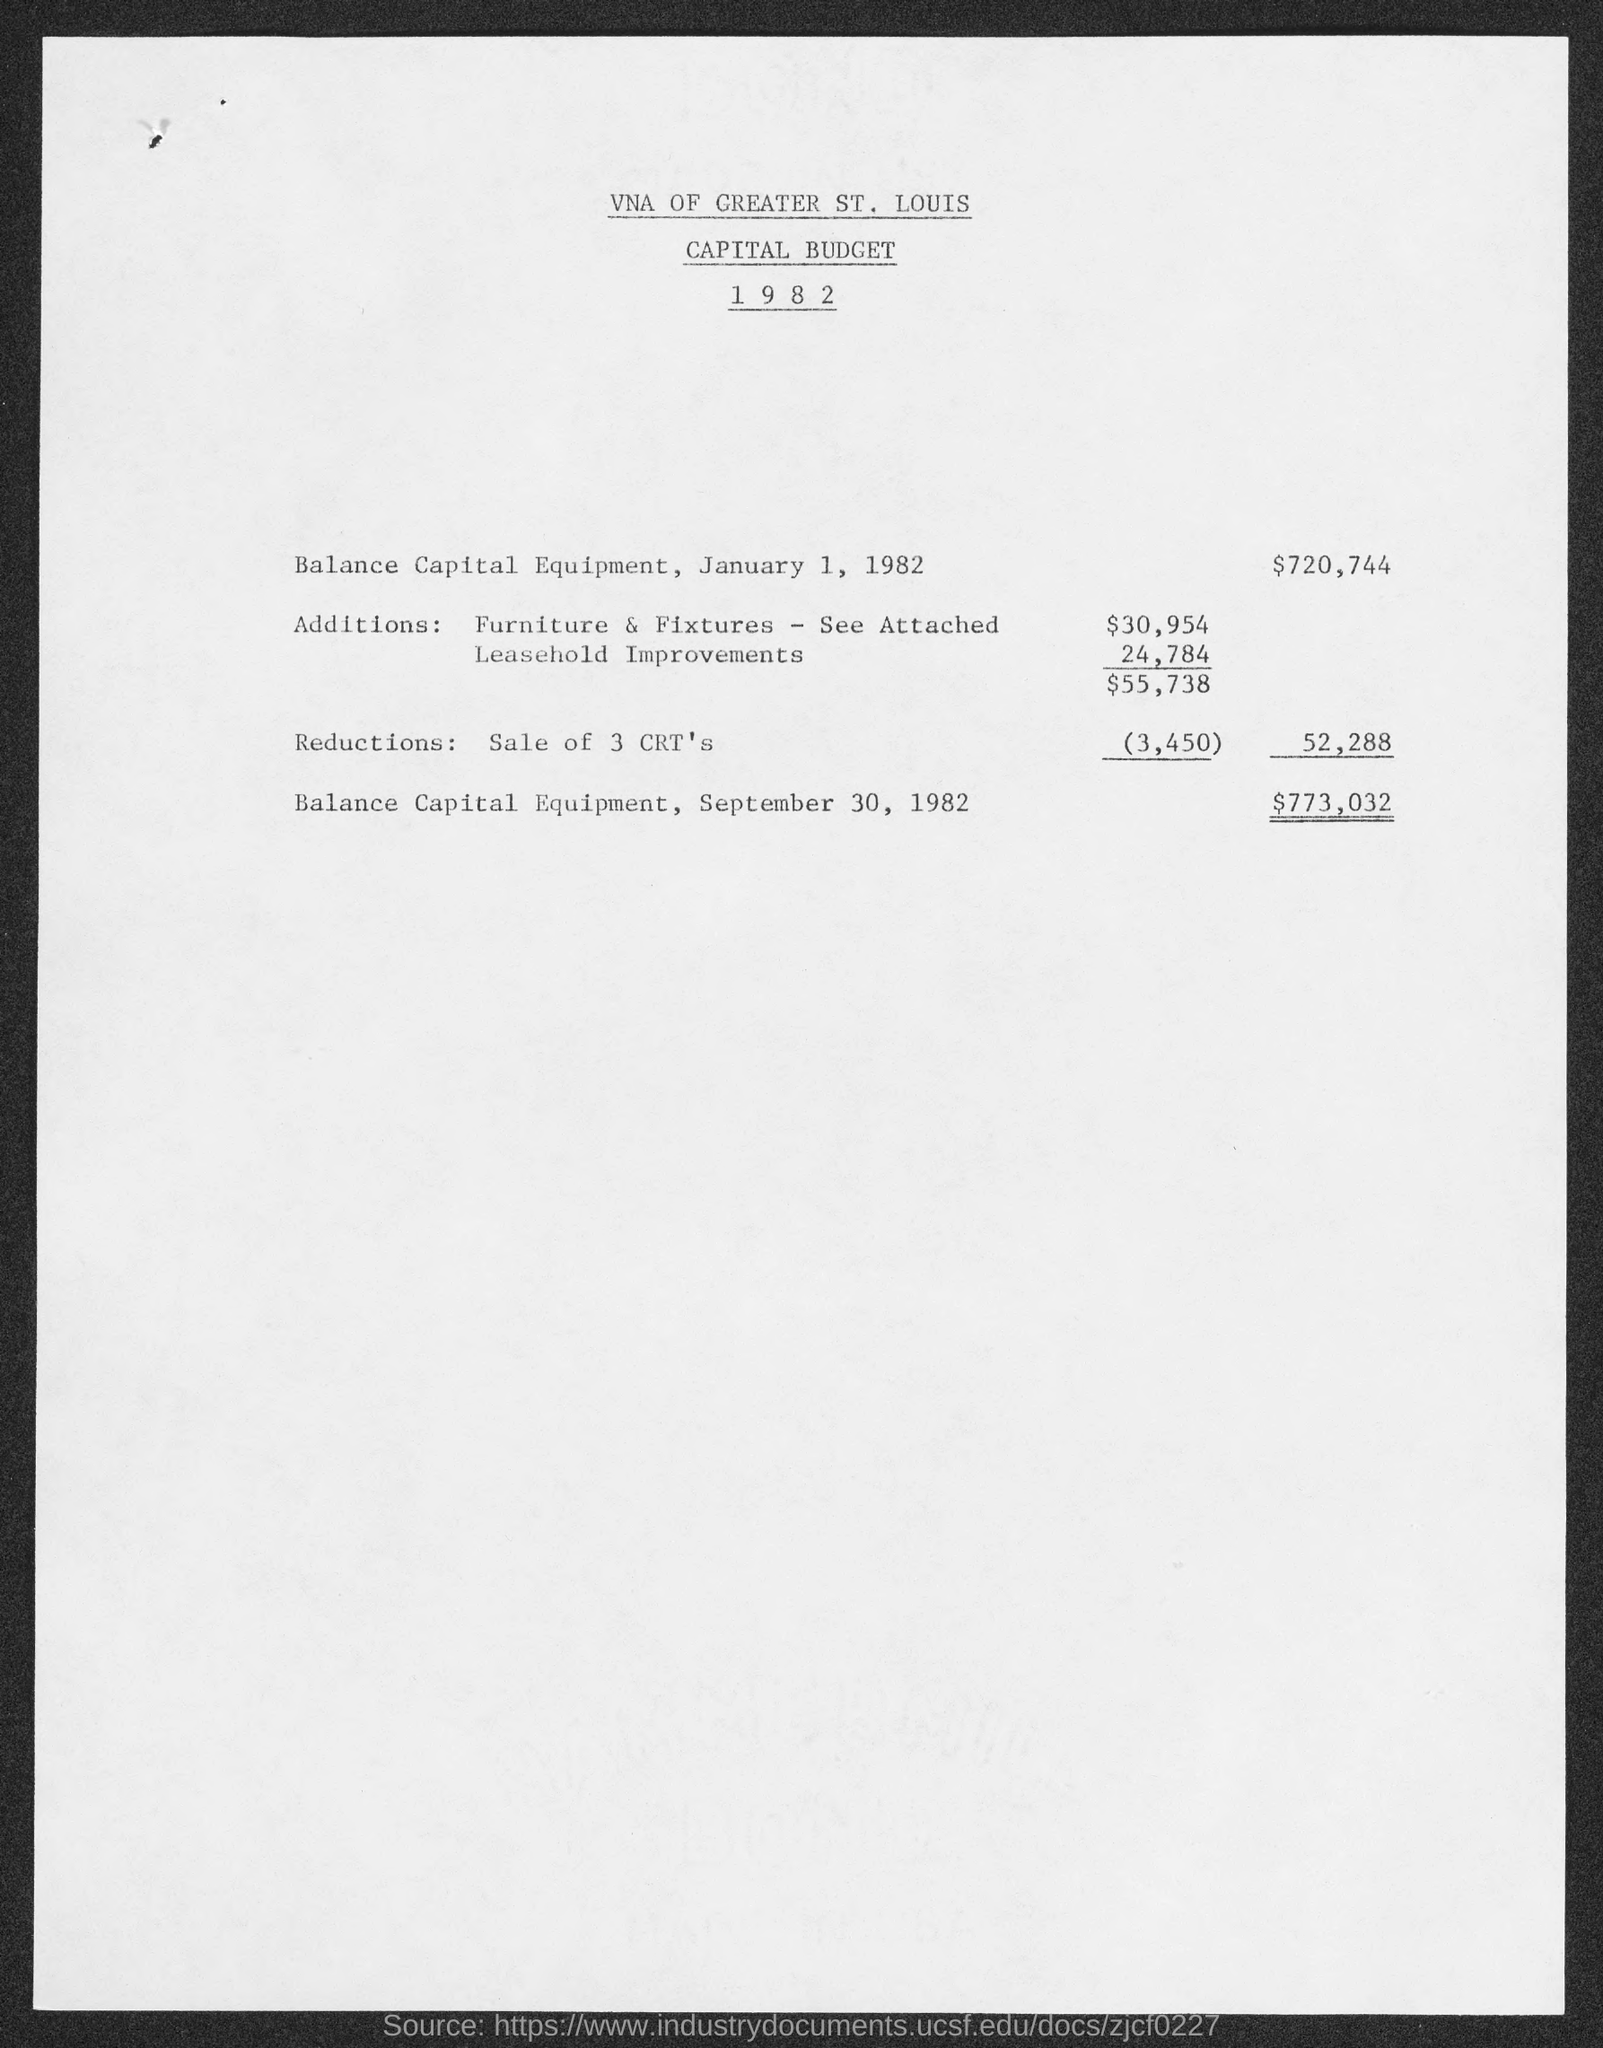Identify some key points in this picture. The balance of capital equipment on September 30, 1982, was $773,032. The balance of capital equipment on January 1, 1982 was $720,744. The Capital Budget 1982 of the VNA of Greater St. Louis is provided. 